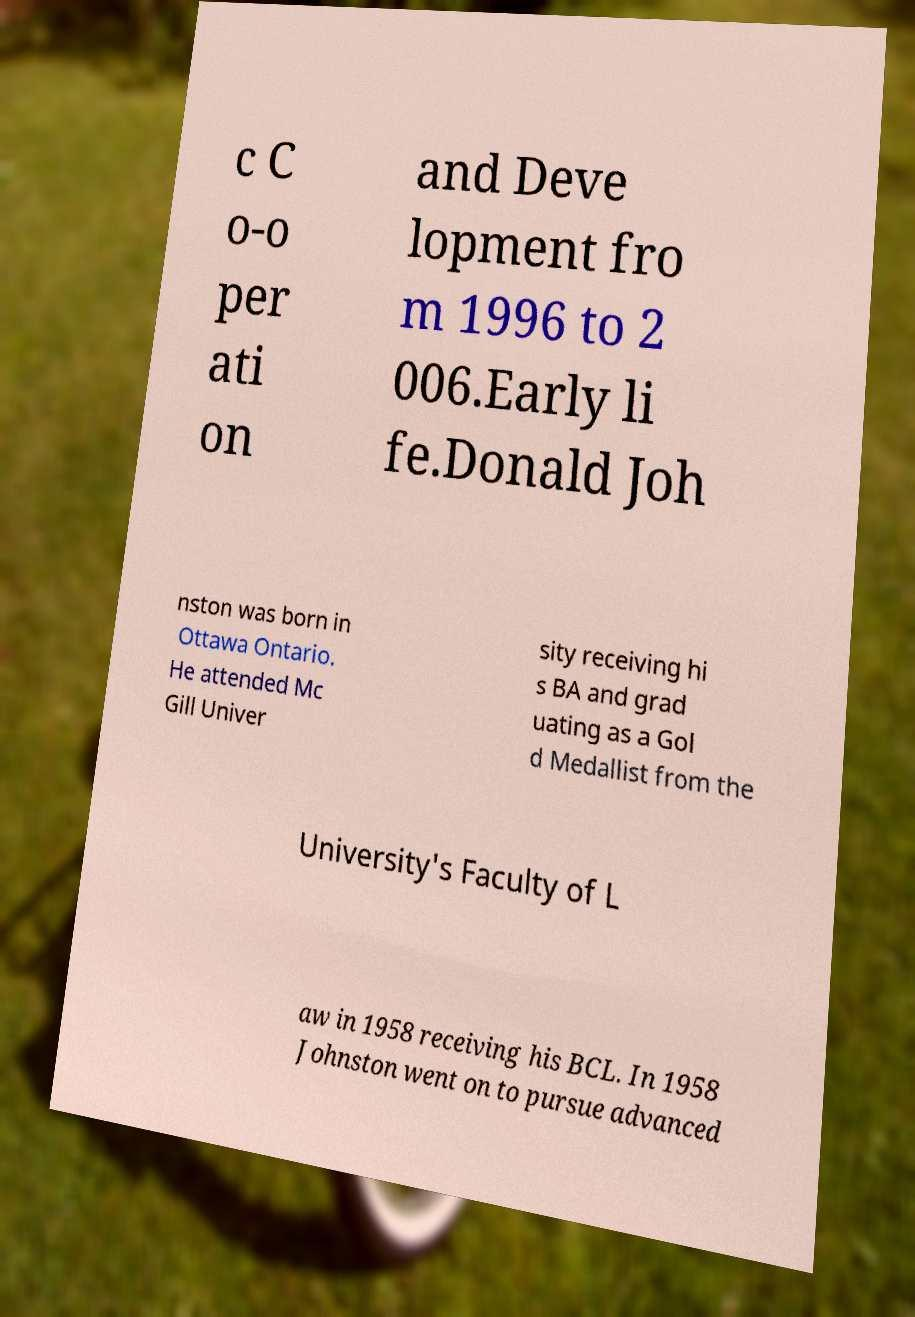What messages or text are displayed in this image? I need them in a readable, typed format. c C o-o per ati on and Deve lopment fro m 1996 to 2 006.Early li fe.Donald Joh nston was born in Ottawa Ontario. He attended Mc Gill Univer sity receiving hi s BA and grad uating as a Gol d Medallist from the University's Faculty of L aw in 1958 receiving his BCL. In 1958 Johnston went on to pursue advanced 